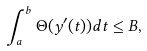Convert formula to latex. <formula><loc_0><loc_0><loc_500><loc_500>\int _ { a } ^ { b } \Theta ( y ^ { \prime } ( t ) ) d t \leq B ,</formula> 